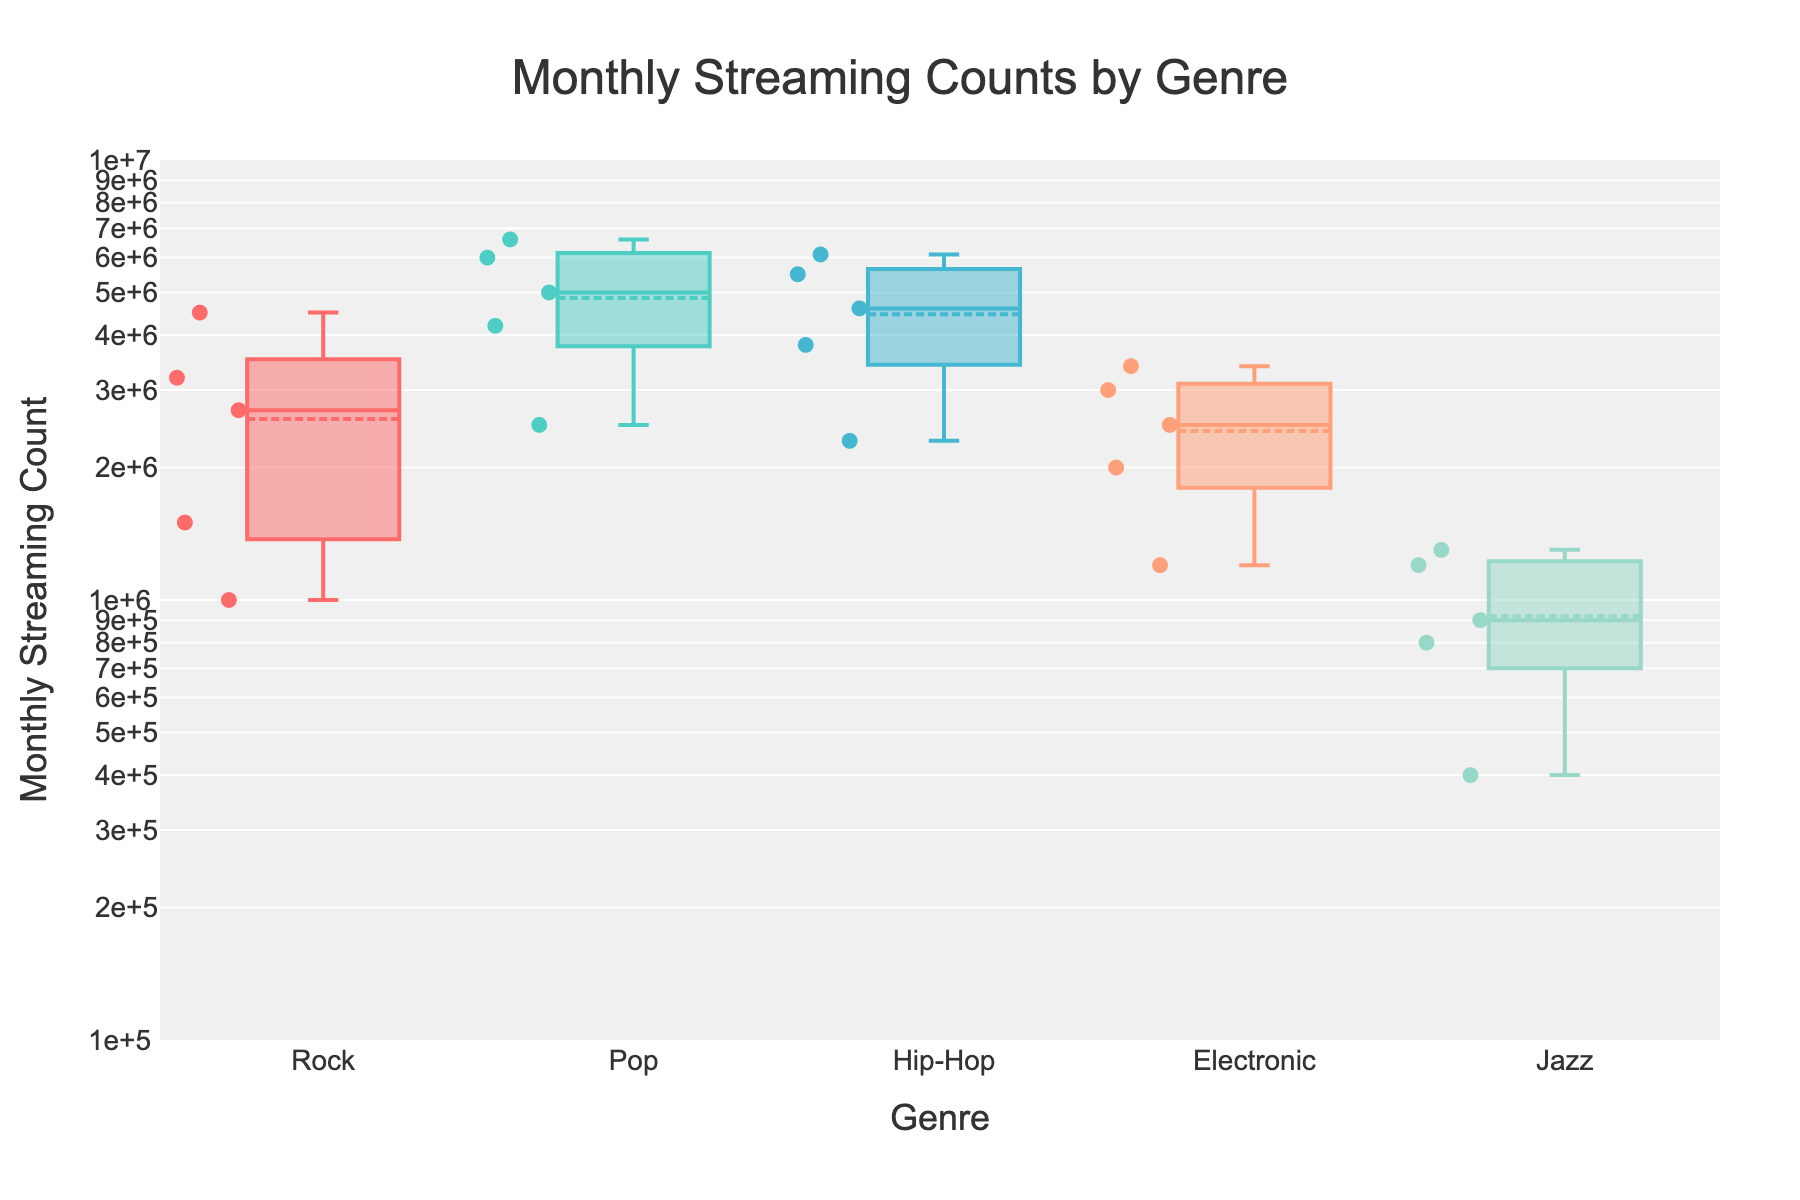what's the title of the figure? The title is prominently placed at the top of the figure and is visually distinguishable.
Answer: Monthly Streaming Counts by Genre which genre has the highest average monthly streaming count? By looking at the mean marker (usually a small line or dot) in each box plot, the genre with the highest mean can be identified.
Answer: Pop how many genres are represented in this figure? Each box plot represents one genre and there are individual markers for each.
Answer: 5 what is the range of monthly streaming counts for Jazz? The range can be identified by the lowest and highest points in the Jazz box plot which represent the minimum and maximum values.
Answer: 400,000 to 1,300,000 which genre shows the widest spread in streaming counts? The spread is determined by the interquartile range (the length of the box). By comparing the widths, the genre with the widest box can be identified.
Answer: Rock which streaming platform is represented by the highest single monthly streaming count in Hip-Hop? Scatter points within the Hip-Hop box plot need to be checked, and the one with the highest value indicates the streaming platform.
Answer: YouTube Music for the Rock genre, which streaming platform has the lowest monthly streaming count? Scatter points within the Rock box plot need to be checked, and the one with the lowest value indicates the streaming platform.
Answer: Tidal do all genres have their mean monthly streaming counts above 1,000,000? The mean markers in each box plot should be checked if they are above or below the 1,000,000 line on the y-axis.
Answer: No which genre has the least variability in monthly streaming counts? The genre with the smallest interquartile range or the shortest box length indicates the least variability.
Answer: Jazz 